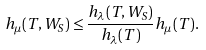Convert formula to latex. <formula><loc_0><loc_0><loc_500><loc_500>h _ { \mu } ( T , W _ { S } ) \leq \frac { h _ { \lambda } ( T , W _ { S } ) } { h _ { \lambda } ( T ) } h _ { \mu } ( T ) .</formula> 